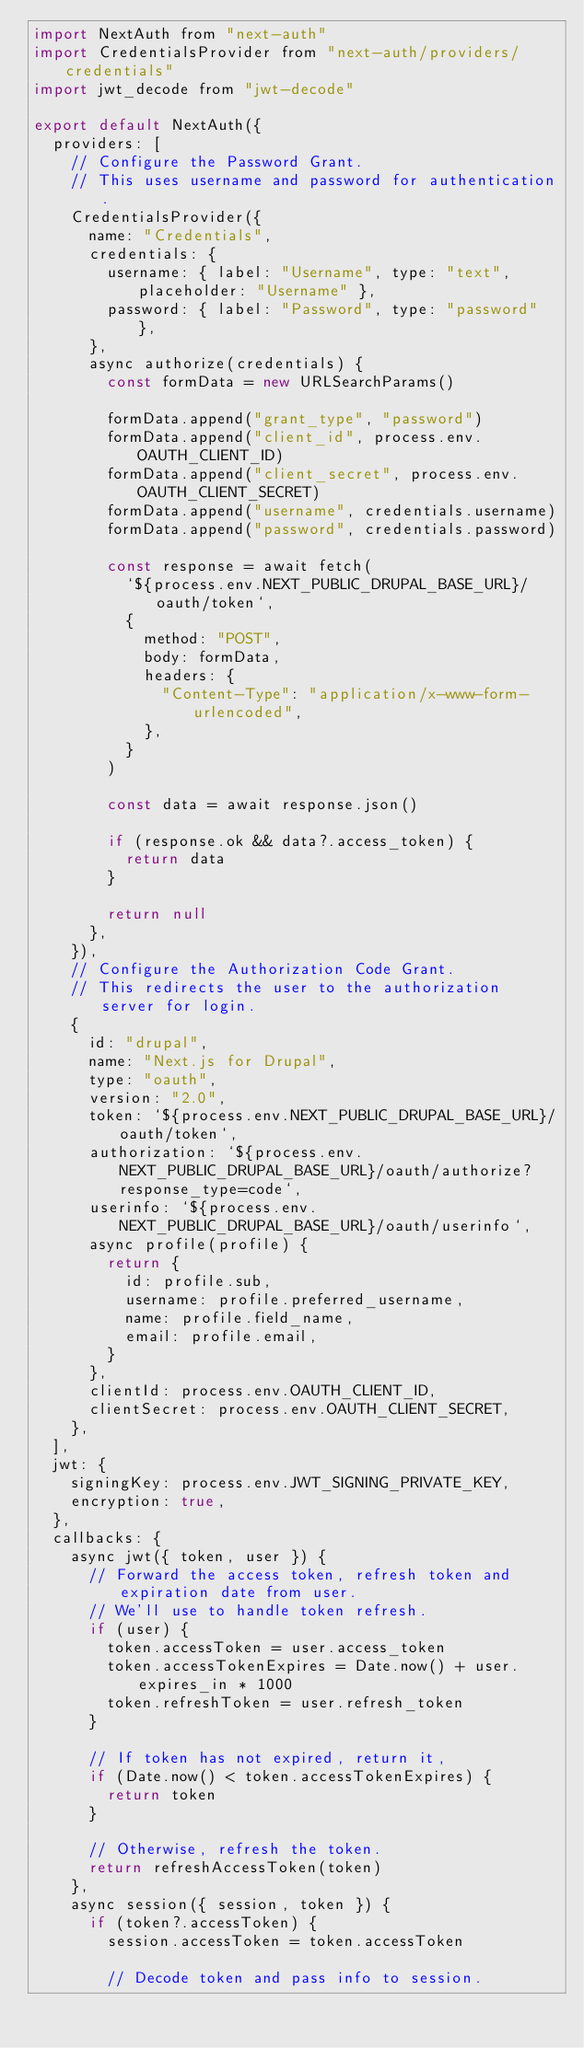Convert code to text. <code><loc_0><loc_0><loc_500><loc_500><_JavaScript_>import NextAuth from "next-auth"
import CredentialsProvider from "next-auth/providers/credentials"
import jwt_decode from "jwt-decode"

export default NextAuth({
  providers: [
    // Configure the Password Grant.
    // This uses username and password for authentication.
    CredentialsProvider({
      name: "Credentials",
      credentials: {
        username: { label: "Username", type: "text", placeholder: "Username" },
        password: { label: "Password", type: "password" },
      },
      async authorize(credentials) {
        const formData = new URLSearchParams()

        formData.append("grant_type", "password")
        formData.append("client_id", process.env.OAUTH_CLIENT_ID)
        formData.append("client_secret", process.env.OAUTH_CLIENT_SECRET)
        formData.append("username", credentials.username)
        formData.append("password", credentials.password)

        const response = await fetch(
          `${process.env.NEXT_PUBLIC_DRUPAL_BASE_URL}/oauth/token`,
          {
            method: "POST",
            body: formData,
            headers: {
              "Content-Type": "application/x-www-form-urlencoded",
            },
          }
        )

        const data = await response.json()

        if (response.ok && data?.access_token) {
          return data
        }

        return null
      },
    }),
    // Configure the Authorization Code Grant.
    // This redirects the user to the authorization server for login.
    {
      id: "drupal",
      name: "Next.js for Drupal",
      type: "oauth",
      version: "2.0",
      token: `${process.env.NEXT_PUBLIC_DRUPAL_BASE_URL}/oauth/token`,
      authorization: `${process.env.NEXT_PUBLIC_DRUPAL_BASE_URL}/oauth/authorize?response_type=code`,
      userinfo: `${process.env.NEXT_PUBLIC_DRUPAL_BASE_URL}/oauth/userinfo`,
      async profile(profile) {
        return {
          id: profile.sub,
          username: profile.preferred_username,
          name: profile.field_name,
          email: profile.email,
        }
      },
      clientId: process.env.OAUTH_CLIENT_ID,
      clientSecret: process.env.OAUTH_CLIENT_SECRET,
    },
  ],
  jwt: {
    signingKey: process.env.JWT_SIGNING_PRIVATE_KEY,
    encryption: true,
  },
  callbacks: {
    async jwt({ token, user }) {
      // Forward the access token, refresh token and expiration date from user.
      // We'll use to handle token refresh.
      if (user) {
        token.accessToken = user.access_token
        token.accessTokenExpires = Date.now() + user.expires_in * 1000
        token.refreshToken = user.refresh_token
      }

      // If token has not expired, return it,
      if (Date.now() < token.accessTokenExpires) {
        return token
      }

      // Otherwise, refresh the token.
      return refreshAccessToken(token)
    },
    async session({ session, token }) {
      if (token?.accessToken) {
        session.accessToken = token.accessToken

        // Decode token and pass info to session.</code> 